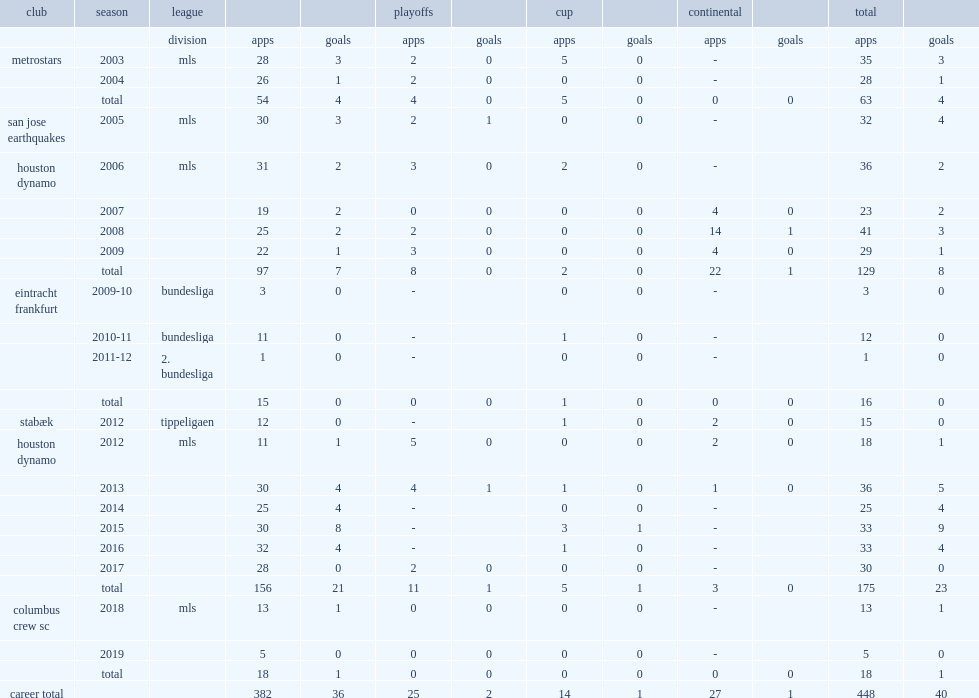Which league did clark play for club eintracht frankfurt in the 2009-10 season? Bundesliga. 